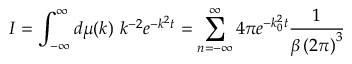Convert formula to latex. <formula><loc_0><loc_0><loc_500><loc_500>I = \int _ { - \infty } ^ { \infty } d \mu ( k ) \, k ^ { - 2 } e ^ { - k ^ { 2 } t } = \sum _ { n = - \infty } ^ { \infty } 4 \pi e ^ { - k _ { 0 } ^ { 2 } t } \frac { 1 } { \beta \left ( 2 \pi \right ) ^ { 3 } }</formula> 